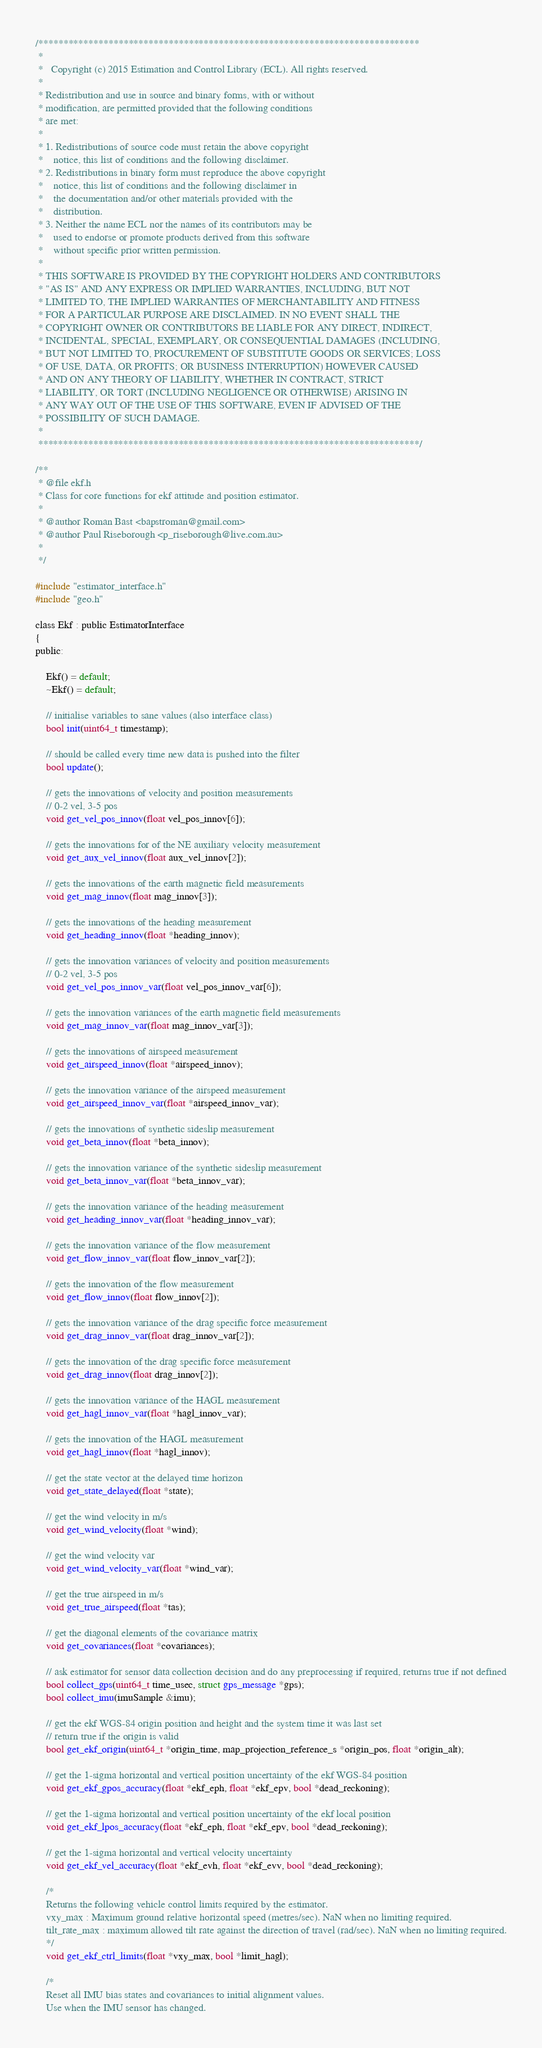Convert code to text. <code><loc_0><loc_0><loc_500><loc_500><_C_>/****************************************************************************
 *
 *   Copyright (c) 2015 Estimation and Control Library (ECL). All rights reserved.
 *
 * Redistribution and use in source and binary forms, with or without
 * modification, are permitted provided that the following conditions
 * are met:
 *
 * 1. Redistributions of source code must retain the above copyright
 *    notice, this list of conditions and the following disclaimer.
 * 2. Redistributions in binary form must reproduce the above copyright
 *    notice, this list of conditions and the following disclaimer in
 *    the documentation and/or other materials provided with the
 *    distribution.
 * 3. Neither the name ECL nor the names of its contributors may be
 *    used to endorse or promote products derived from this software
 *    without specific prior written permission.
 *
 * THIS SOFTWARE IS PROVIDED BY THE COPYRIGHT HOLDERS AND CONTRIBUTORS
 * "AS IS" AND ANY EXPRESS OR IMPLIED WARRANTIES, INCLUDING, BUT NOT
 * LIMITED TO, THE IMPLIED WARRANTIES OF MERCHANTABILITY AND FITNESS
 * FOR A PARTICULAR PURPOSE ARE DISCLAIMED. IN NO EVENT SHALL THE
 * COPYRIGHT OWNER OR CONTRIBUTORS BE LIABLE FOR ANY DIRECT, INDIRECT,
 * INCIDENTAL, SPECIAL, EXEMPLARY, OR CONSEQUENTIAL DAMAGES (INCLUDING,
 * BUT NOT LIMITED TO, PROCUREMENT OF SUBSTITUTE GOODS OR SERVICES; LOSS
 * OF USE, DATA, OR PROFITS; OR BUSINESS INTERRUPTION) HOWEVER CAUSED
 * AND ON ANY THEORY OF LIABILITY, WHETHER IN CONTRACT, STRICT
 * LIABILITY, OR TORT (INCLUDING NEGLIGENCE OR OTHERWISE) ARISING IN
 * ANY WAY OUT OF THE USE OF THIS SOFTWARE, EVEN IF ADVISED OF THE
 * POSSIBILITY OF SUCH DAMAGE.
 *
 ****************************************************************************/

/**
 * @file ekf.h
 * Class for core functions for ekf attitude and position estimator.
 *
 * @author Roman Bast <bapstroman@gmail.com>
 * @author Paul Riseborough <p_riseborough@live.com.au>
 *
 */

#include "estimator_interface.h"
#include "geo.h"

class Ekf : public EstimatorInterface
{
public:

	Ekf() = default;
	~Ekf() = default;

	// initialise variables to sane values (also interface class)
	bool init(uint64_t timestamp);

	// should be called every time new data is pushed into the filter
	bool update();

	// gets the innovations of velocity and position measurements
	// 0-2 vel, 3-5 pos
	void get_vel_pos_innov(float vel_pos_innov[6]);

	// gets the innovations for of the NE auxiliary velocity measurement
	void get_aux_vel_innov(float aux_vel_innov[2]);

	// gets the innovations of the earth magnetic field measurements
	void get_mag_innov(float mag_innov[3]);

	// gets the innovations of the heading measurement
	void get_heading_innov(float *heading_innov);

	// gets the innovation variances of velocity and position measurements
	// 0-2 vel, 3-5 pos
	void get_vel_pos_innov_var(float vel_pos_innov_var[6]);

	// gets the innovation variances of the earth magnetic field measurements
	void get_mag_innov_var(float mag_innov_var[3]);

	// gets the innovations of airspeed measurement
	void get_airspeed_innov(float *airspeed_innov);

	// gets the innovation variance of the airspeed measurement
	void get_airspeed_innov_var(float *airspeed_innov_var);

	// gets the innovations of synthetic sideslip measurement
	void get_beta_innov(float *beta_innov);

	// gets the innovation variance of the synthetic sideslip measurement
	void get_beta_innov_var(float *beta_innov_var);

	// gets the innovation variance of the heading measurement
	void get_heading_innov_var(float *heading_innov_var);

	// gets the innovation variance of the flow measurement
	void get_flow_innov_var(float flow_innov_var[2]);

	// gets the innovation of the flow measurement
	void get_flow_innov(float flow_innov[2]);

	// gets the innovation variance of the drag specific force measurement
	void get_drag_innov_var(float drag_innov_var[2]);

	// gets the innovation of the drag specific force measurement
	void get_drag_innov(float drag_innov[2]);

	// gets the innovation variance of the HAGL measurement
	void get_hagl_innov_var(float *hagl_innov_var);

	// gets the innovation of the HAGL measurement
	void get_hagl_innov(float *hagl_innov);

	// get the state vector at the delayed time horizon
	void get_state_delayed(float *state);

	// get the wind velocity in m/s
	void get_wind_velocity(float *wind);

	// get the wind velocity var
	void get_wind_velocity_var(float *wind_var);

	// get the true airspeed in m/s
	void get_true_airspeed(float *tas);

	// get the diagonal elements of the covariance matrix
	void get_covariances(float *covariances);

	// ask estimator for sensor data collection decision and do any preprocessing if required, returns true if not defined
	bool collect_gps(uint64_t time_usec, struct gps_message *gps);
	bool collect_imu(imuSample &imu);

	// get the ekf WGS-84 origin position and height and the system time it was last set
	// return true if the origin is valid
	bool get_ekf_origin(uint64_t *origin_time, map_projection_reference_s *origin_pos, float *origin_alt);

	// get the 1-sigma horizontal and vertical position uncertainty of the ekf WGS-84 position
	void get_ekf_gpos_accuracy(float *ekf_eph, float *ekf_epv, bool *dead_reckoning);

	// get the 1-sigma horizontal and vertical position uncertainty of the ekf local position
	void get_ekf_lpos_accuracy(float *ekf_eph, float *ekf_epv, bool *dead_reckoning);

	// get the 1-sigma horizontal and vertical velocity uncertainty
	void get_ekf_vel_accuracy(float *ekf_evh, float *ekf_evv, bool *dead_reckoning);

	/*
	Returns the following vehicle control limits required by the estimator.
	vxy_max : Maximum ground relative horizontal speed (metres/sec). NaN when no limiting required.
	tilt_rate_max : maximum allowed tilt rate against the direction of travel (rad/sec). NaN when no limiting required.
	*/
	void get_ekf_ctrl_limits(float *vxy_max, bool *limit_hagl);

	/*
	Reset all IMU bias states and covariances to initial alignment values.
	Use when the IMU sensor has changed.</code> 